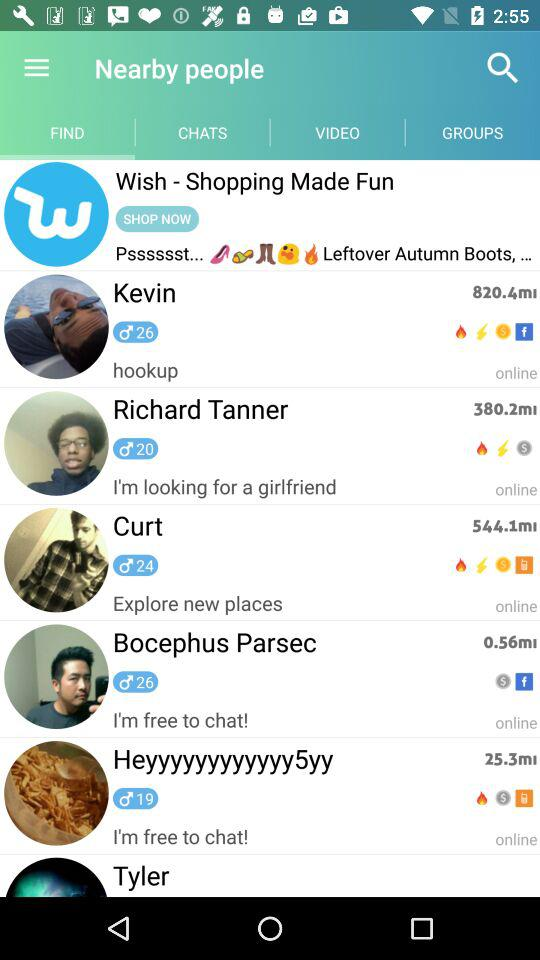What is the status of Richard Tanner? Richard Tanner is online. 